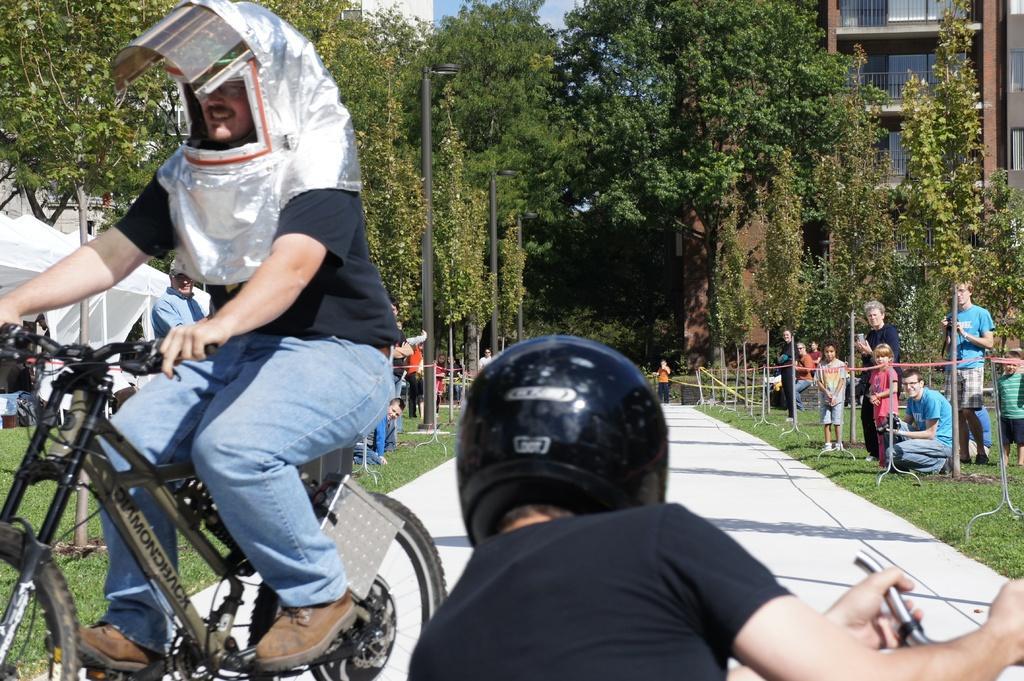Please provide a concise description of this image. this picture shows a man wearing a helmet and riding a bicycle and we see a other man riding and we see few people standing and watching them and we see trees around and a building 